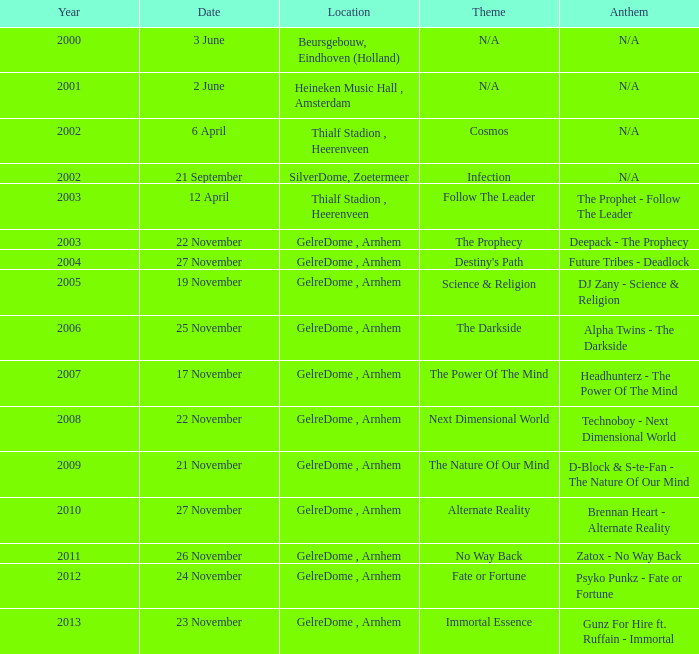What date has a theme of fate or fortune? 24 November. 